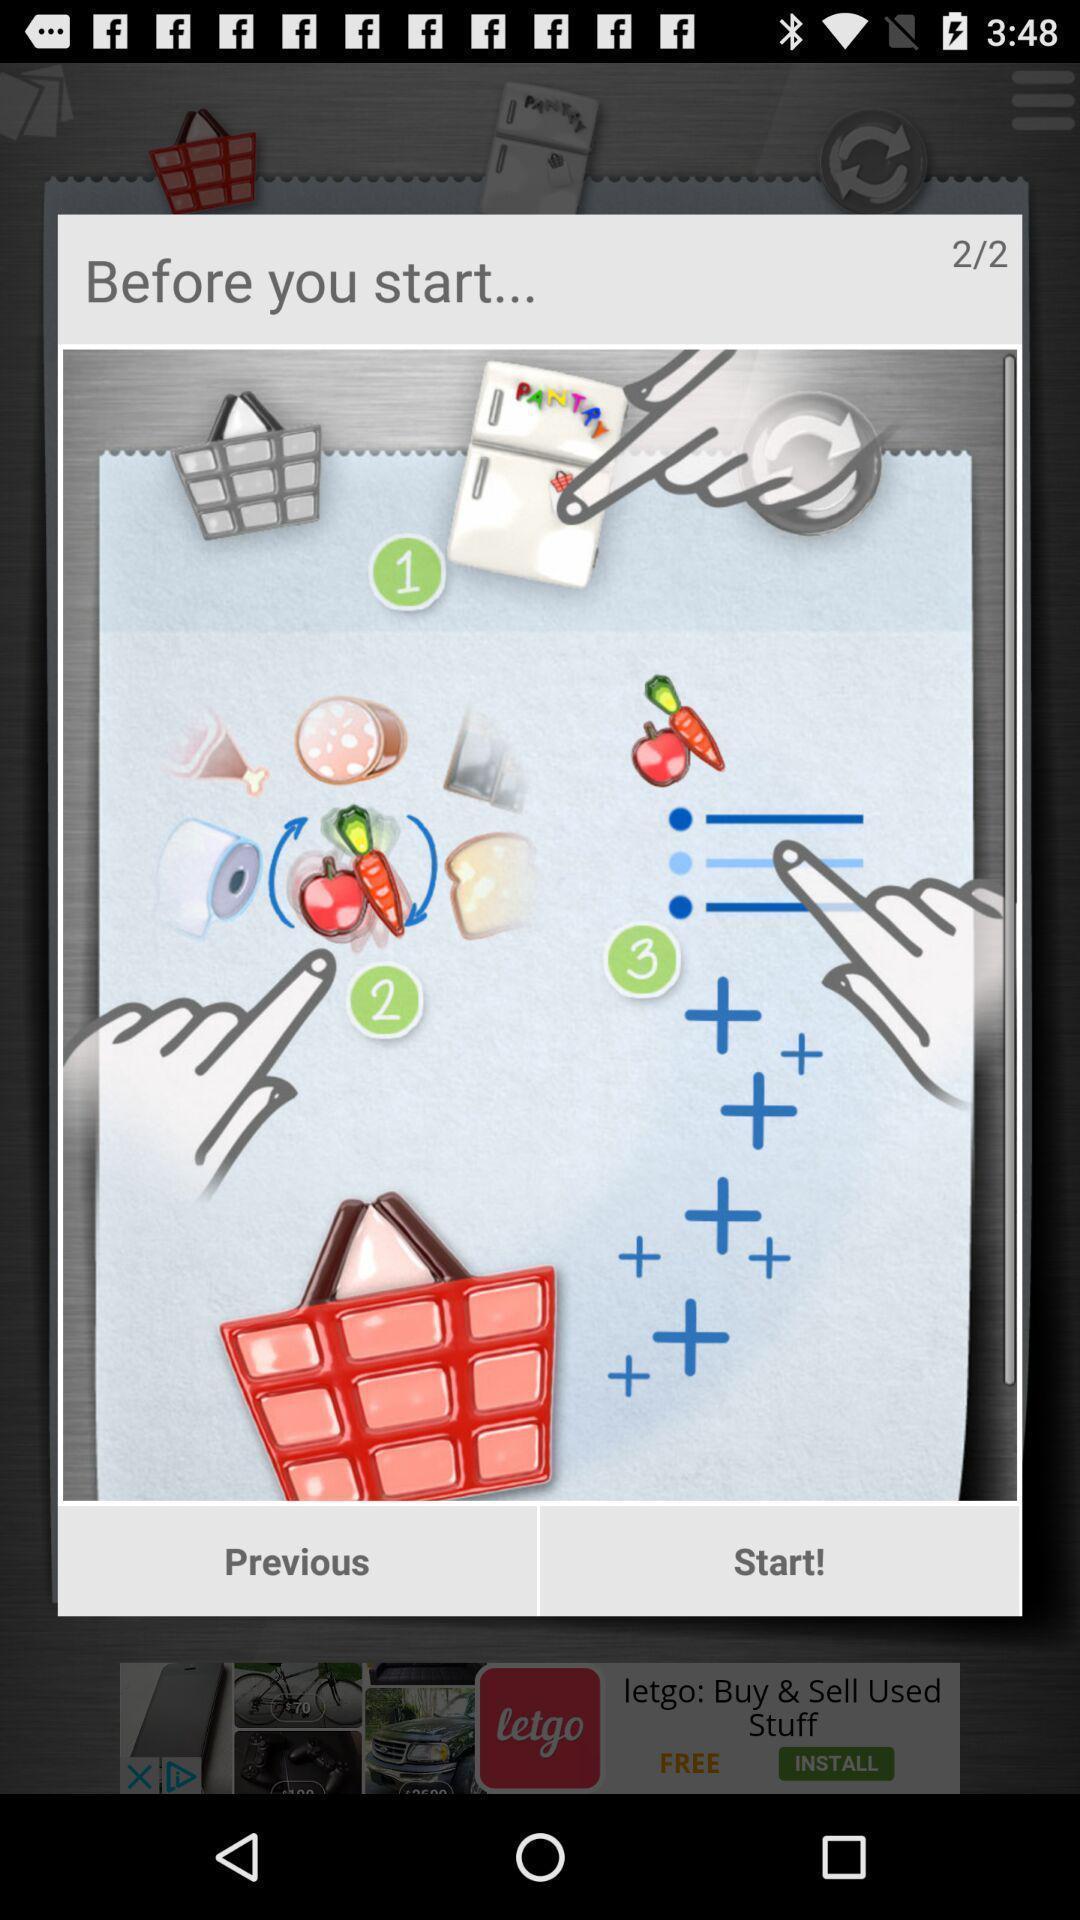Explain what's happening in this screen capture. Pop-up displaying with few image icons and options. 